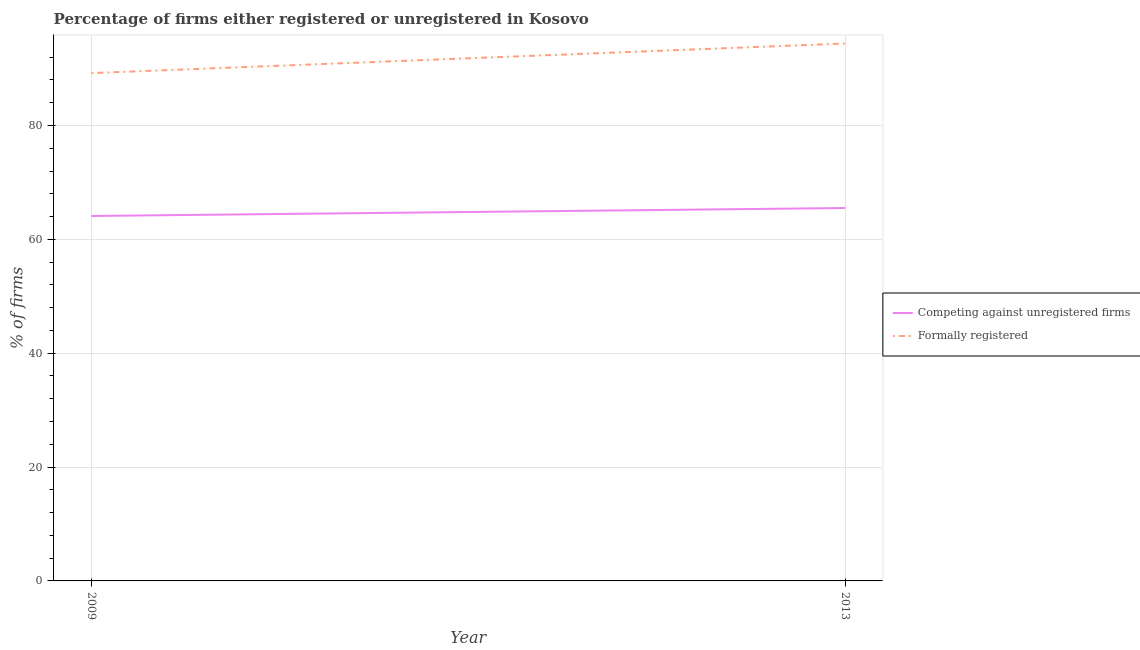Does the line corresponding to percentage of registered firms intersect with the line corresponding to percentage of formally registered firms?
Ensure brevity in your answer.  No. Is the number of lines equal to the number of legend labels?
Provide a succinct answer. Yes. What is the percentage of registered firms in 2013?
Provide a short and direct response. 65.5. Across all years, what is the maximum percentage of registered firms?
Make the answer very short. 65.5. Across all years, what is the minimum percentage of registered firms?
Provide a succinct answer. 64.1. What is the total percentage of formally registered firms in the graph?
Give a very brief answer. 183.6. What is the difference between the percentage of registered firms in 2009 and that in 2013?
Your answer should be very brief. -1.4. What is the difference between the percentage of registered firms in 2009 and the percentage of formally registered firms in 2013?
Provide a succinct answer. -30.3. What is the average percentage of registered firms per year?
Ensure brevity in your answer.  64.8. In the year 2013, what is the difference between the percentage of formally registered firms and percentage of registered firms?
Ensure brevity in your answer.  28.9. In how many years, is the percentage of registered firms greater than 44 %?
Your response must be concise. 2. What is the ratio of the percentage of formally registered firms in 2009 to that in 2013?
Keep it short and to the point. 0.94. In how many years, is the percentage of registered firms greater than the average percentage of registered firms taken over all years?
Your answer should be compact. 1. Is the percentage of registered firms strictly greater than the percentage of formally registered firms over the years?
Provide a succinct answer. No. How many years are there in the graph?
Give a very brief answer. 2. What is the difference between two consecutive major ticks on the Y-axis?
Your response must be concise. 20. Does the graph contain grids?
Offer a terse response. Yes. Where does the legend appear in the graph?
Provide a succinct answer. Center right. How many legend labels are there?
Make the answer very short. 2. How are the legend labels stacked?
Give a very brief answer. Vertical. What is the title of the graph?
Provide a short and direct response. Percentage of firms either registered or unregistered in Kosovo. Does "Short-term debt" appear as one of the legend labels in the graph?
Your answer should be very brief. No. What is the label or title of the X-axis?
Make the answer very short. Year. What is the label or title of the Y-axis?
Keep it short and to the point. % of firms. What is the % of firms of Competing against unregistered firms in 2009?
Ensure brevity in your answer.  64.1. What is the % of firms in Formally registered in 2009?
Your response must be concise. 89.2. What is the % of firms of Competing against unregistered firms in 2013?
Offer a very short reply. 65.5. What is the % of firms of Formally registered in 2013?
Make the answer very short. 94.4. Across all years, what is the maximum % of firms in Competing against unregistered firms?
Offer a very short reply. 65.5. Across all years, what is the maximum % of firms of Formally registered?
Give a very brief answer. 94.4. Across all years, what is the minimum % of firms of Competing against unregistered firms?
Ensure brevity in your answer.  64.1. Across all years, what is the minimum % of firms in Formally registered?
Give a very brief answer. 89.2. What is the total % of firms of Competing against unregistered firms in the graph?
Provide a short and direct response. 129.6. What is the total % of firms in Formally registered in the graph?
Provide a short and direct response. 183.6. What is the difference between the % of firms in Competing against unregistered firms in 2009 and the % of firms in Formally registered in 2013?
Your response must be concise. -30.3. What is the average % of firms in Competing against unregistered firms per year?
Make the answer very short. 64.8. What is the average % of firms of Formally registered per year?
Your response must be concise. 91.8. In the year 2009, what is the difference between the % of firms in Competing against unregistered firms and % of firms in Formally registered?
Give a very brief answer. -25.1. In the year 2013, what is the difference between the % of firms of Competing against unregistered firms and % of firms of Formally registered?
Ensure brevity in your answer.  -28.9. What is the ratio of the % of firms in Competing against unregistered firms in 2009 to that in 2013?
Offer a terse response. 0.98. What is the ratio of the % of firms of Formally registered in 2009 to that in 2013?
Give a very brief answer. 0.94. What is the difference between the highest and the second highest % of firms in Competing against unregistered firms?
Your answer should be very brief. 1.4. What is the difference between the highest and the lowest % of firms of Competing against unregistered firms?
Ensure brevity in your answer.  1.4. 